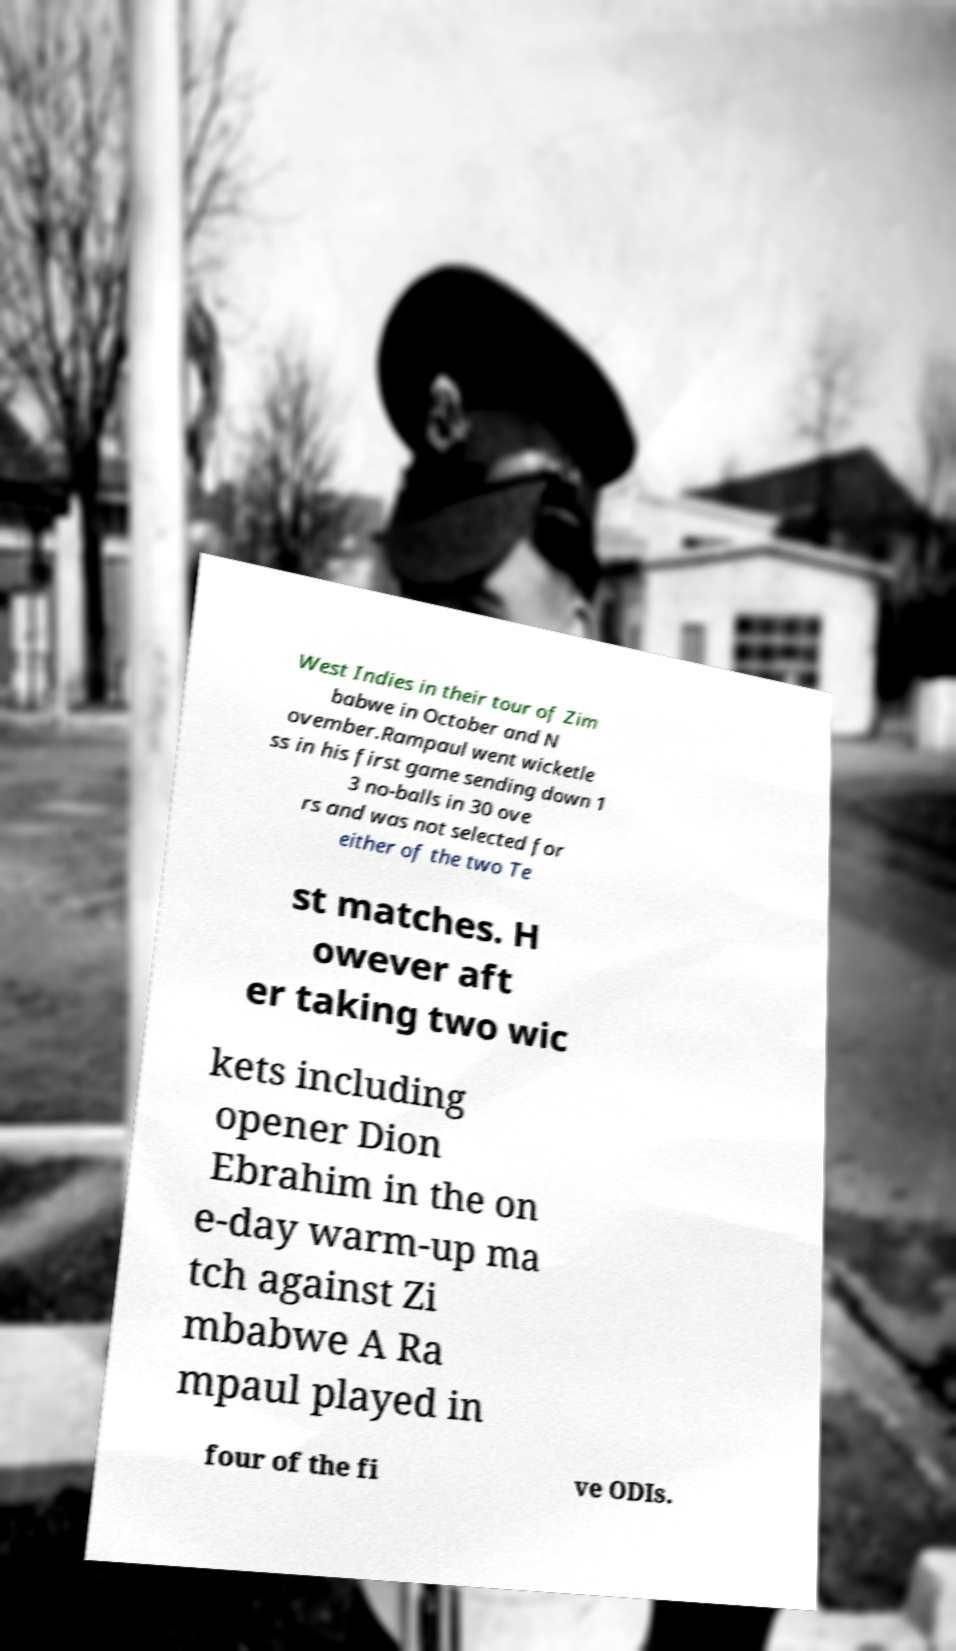Can you accurately transcribe the text from the provided image for me? West Indies in their tour of Zim babwe in October and N ovember.Rampaul went wicketle ss in his first game sending down 1 3 no-balls in 30 ove rs and was not selected for either of the two Te st matches. H owever aft er taking two wic kets including opener Dion Ebrahim in the on e-day warm-up ma tch against Zi mbabwe A Ra mpaul played in four of the fi ve ODIs. 